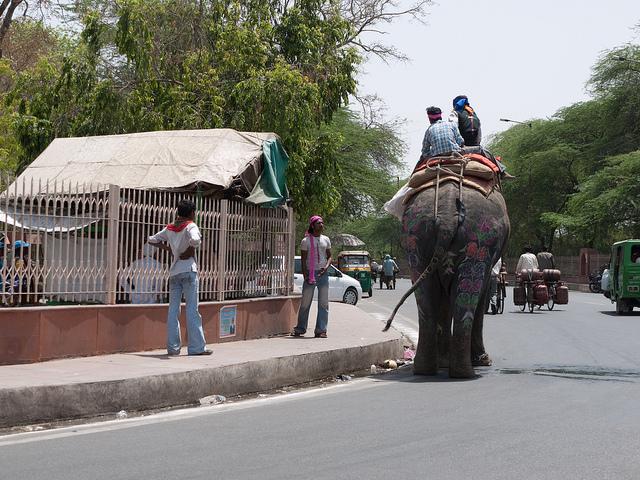How many people are on the elephant?
Quick response, please. 2. How many elephants do you see?
Keep it brief. 1. Is the elephant walking near the sidewalk?
Short answer required. Yes. 